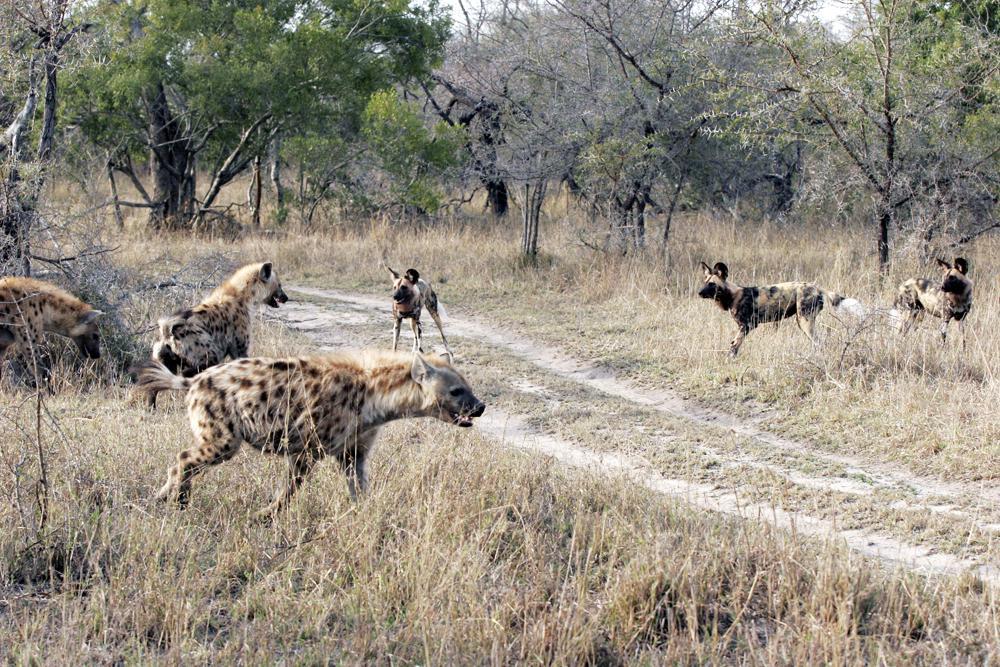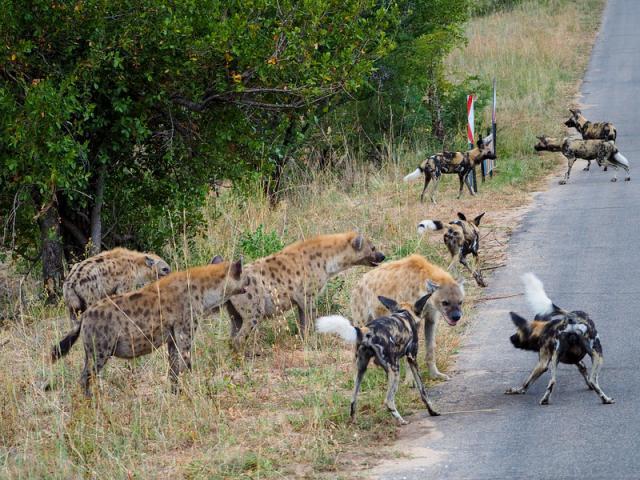The first image is the image on the left, the second image is the image on the right. Examine the images to the left and right. Is the description "An image shows at least six hyenas, with multicolored fur featuring blotches of color instead of spots, standing around a watering hole." accurate? Answer yes or no. No. The first image is the image on the left, the second image is the image on the right. For the images displayed, is the sentence "There are at least six wild dogs are standing on the shore line." factually correct? Answer yes or no. No. 